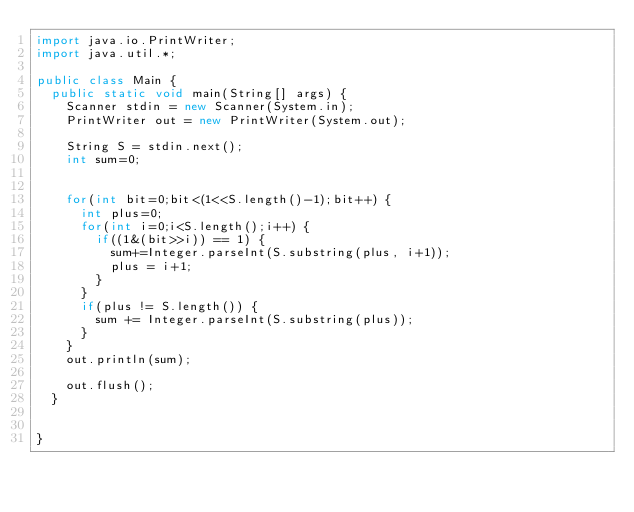<code> <loc_0><loc_0><loc_500><loc_500><_Java_>import java.io.PrintWriter;
import java.util.*;

public class Main {
	public static void main(String[] args) {
		Scanner stdin = new Scanner(System.in);
		PrintWriter out = new PrintWriter(System.out);
		
		String S = stdin.next();
		int sum=0;
		
		
		for(int bit=0;bit<(1<<S.length()-1);bit++) {
			int plus=0;
			for(int i=0;i<S.length();i++) {
				if((1&(bit>>i)) == 1) {
					sum+=Integer.parseInt(S.substring(plus, i+1));
					plus = i+1;
				}	
			}
			if(plus != S.length()) {
				sum += Integer.parseInt(S.substring(plus));
			}
		}
		out.println(sum);

		out.flush();
	}

	
}</code> 